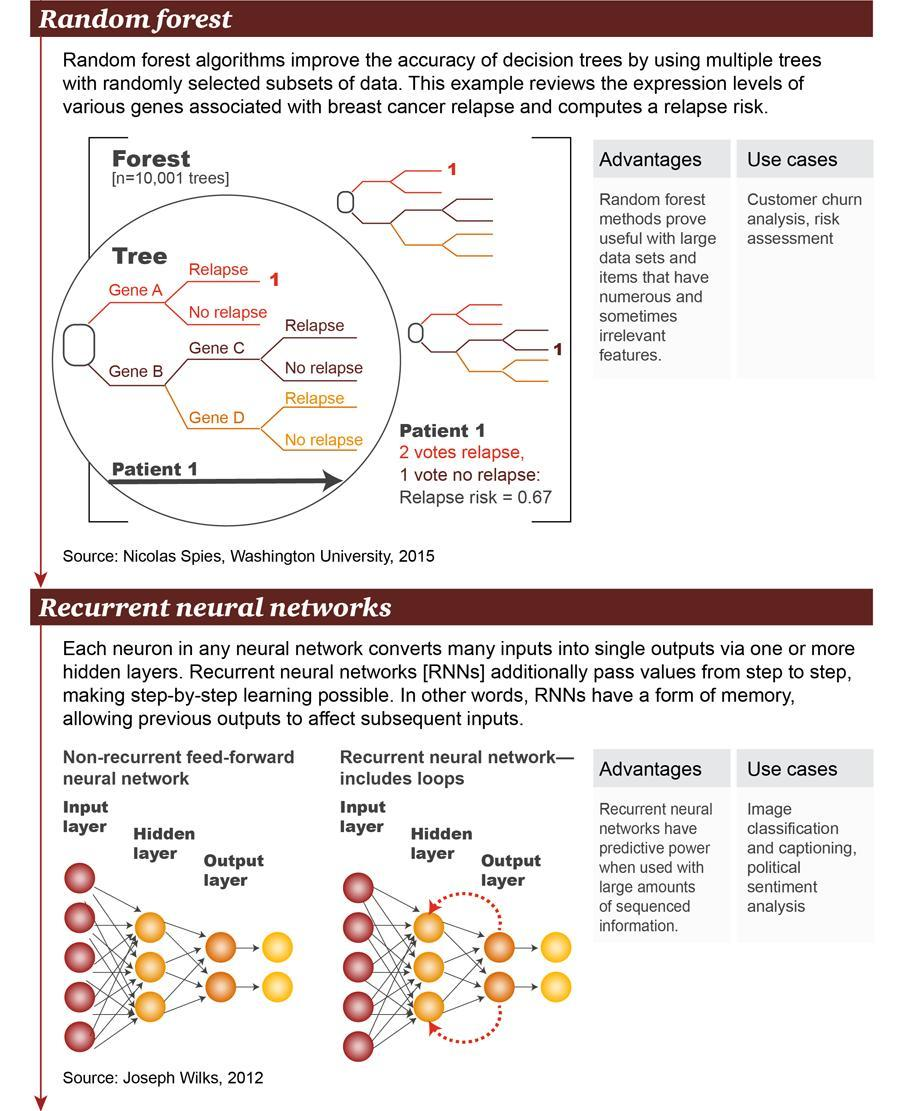Which is the color given to map Gene D- orange, yellow, magenta, blue?
Answer the question with a short phrase. yellow What are the different layers of Neural Networks? Input Layer, Hidden Layer, Output Layer How many layers are there for the Neural Networks? 3 Which are the genes originating from Gene B? Gene C, Gene D Which is the middle layer of Neural Network? Hidden Layer Which are the Genes originating from the Tree Root? Gene A, Gene B 